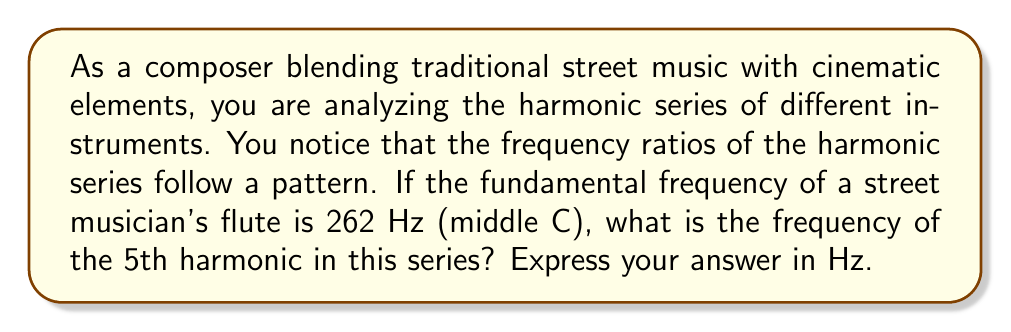Show me your answer to this math problem. To solve this problem, we need to understand the harmonic series and how it relates to frequency ratios:

1) The harmonic series is a sequence of frequencies that are integer multiples of a fundamental frequency.

2) The mathematical representation of the harmonic series is:

   $$f_n = n \cdot f_1$$

   Where:
   $f_n$ is the frequency of the nth harmonic
   $n$ is the harmonic number (1, 2, 3, ...)
   $f_1$ is the fundamental frequency

3) In this case:
   $f_1 = 262$ Hz (the fundamental frequency)
   We're asked to find $f_5$ (the 5th harmonic)

4) Applying the formula:

   $$f_5 = 5 \cdot f_1$$
   $$f_5 = 5 \cdot 262$$
   $$f_5 = 1310$$ Hz

Therefore, the frequency of the 5th harmonic is 1310 Hz.

This analysis is crucial for understanding the timbral characteristics of different instruments, which is essential when blending traditional street music with cinematic elements. The harmonic series contributes significantly to an instrument's unique sound color.
Answer: 1310 Hz 